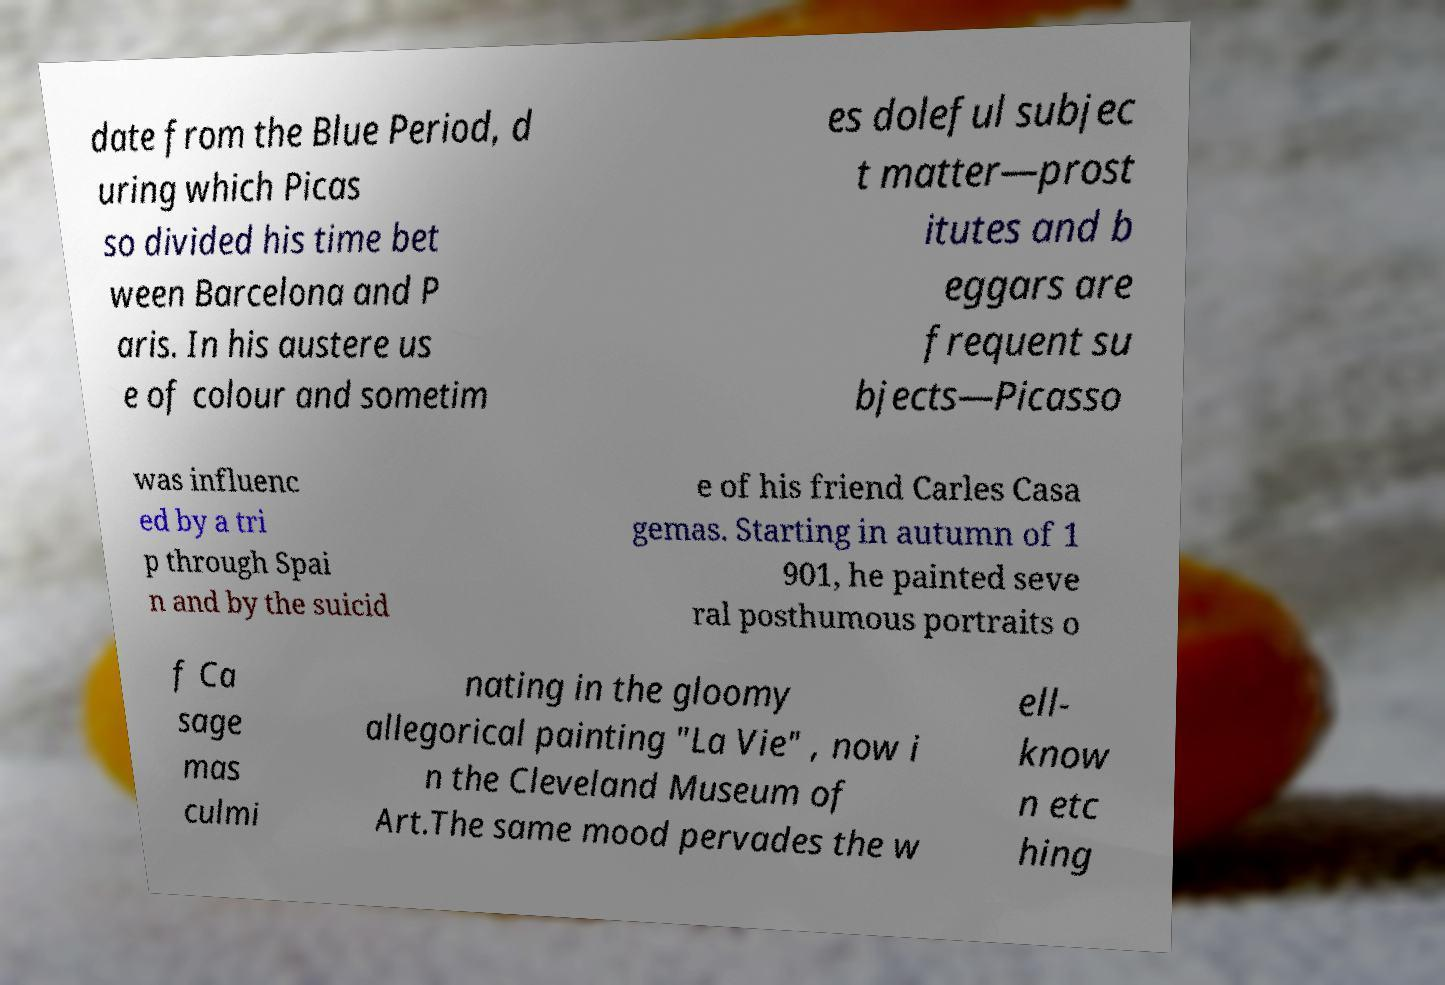Please identify and transcribe the text found in this image. date from the Blue Period, d uring which Picas so divided his time bet ween Barcelona and P aris. In his austere us e of colour and sometim es doleful subjec t matter—prost itutes and b eggars are frequent su bjects—Picasso was influenc ed by a tri p through Spai n and by the suicid e of his friend Carles Casa gemas. Starting in autumn of 1 901, he painted seve ral posthumous portraits o f Ca sage mas culmi nating in the gloomy allegorical painting "La Vie" , now i n the Cleveland Museum of Art.The same mood pervades the w ell- know n etc hing 